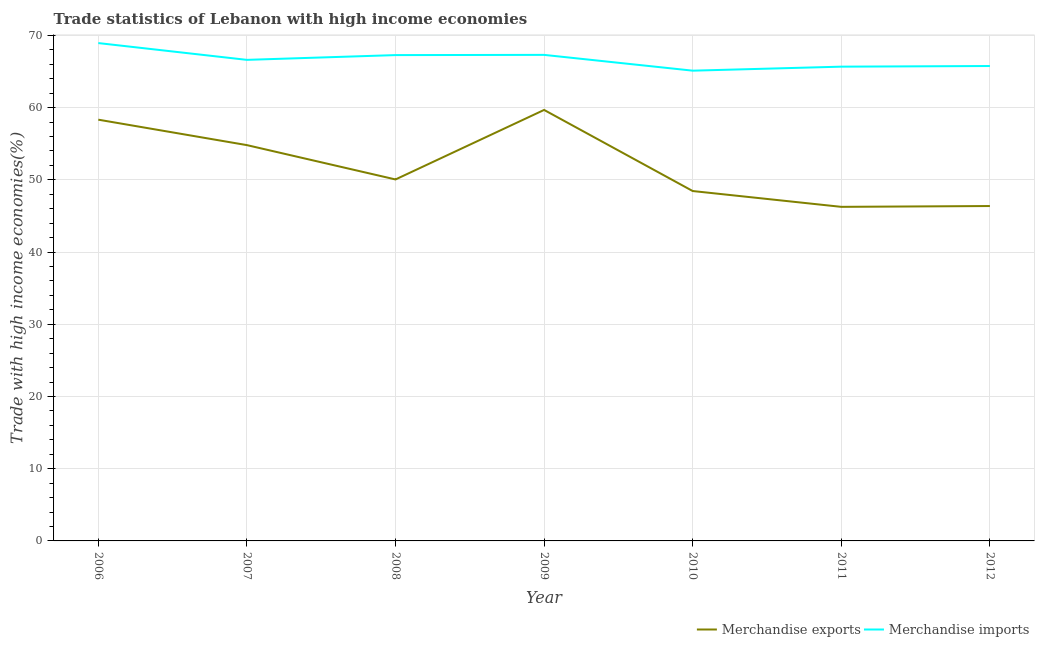How many different coloured lines are there?
Offer a terse response. 2. What is the merchandise exports in 2009?
Your answer should be compact. 59.68. Across all years, what is the maximum merchandise exports?
Your response must be concise. 59.68. Across all years, what is the minimum merchandise exports?
Provide a succinct answer. 46.26. In which year was the merchandise imports minimum?
Make the answer very short. 2010. What is the total merchandise exports in the graph?
Your response must be concise. 363.94. What is the difference between the merchandise exports in 2011 and that in 2012?
Your response must be concise. -0.11. What is the difference between the merchandise exports in 2012 and the merchandise imports in 2008?
Offer a terse response. -20.9. What is the average merchandise exports per year?
Offer a very short reply. 51.99. In the year 2007, what is the difference between the merchandise imports and merchandise exports?
Your answer should be very brief. 11.81. In how many years, is the merchandise imports greater than 12 %?
Keep it short and to the point. 7. What is the ratio of the merchandise exports in 2006 to that in 2012?
Make the answer very short. 1.26. What is the difference between the highest and the second highest merchandise imports?
Offer a very short reply. 1.64. What is the difference between the highest and the lowest merchandise exports?
Give a very brief answer. 13.42. Is the sum of the merchandise exports in 2006 and 2008 greater than the maximum merchandise imports across all years?
Your answer should be very brief. Yes. Is the merchandise exports strictly greater than the merchandise imports over the years?
Provide a short and direct response. No. Is the merchandise exports strictly less than the merchandise imports over the years?
Keep it short and to the point. Yes. How many lines are there?
Offer a terse response. 2. Are the values on the major ticks of Y-axis written in scientific E-notation?
Offer a terse response. No. Does the graph contain any zero values?
Provide a short and direct response. No. Where does the legend appear in the graph?
Your response must be concise. Bottom right. How are the legend labels stacked?
Provide a short and direct response. Horizontal. What is the title of the graph?
Provide a short and direct response. Trade statistics of Lebanon with high income economies. What is the label or title of the X-axis?
Your answer should be very brief. Year. What is the label or title of the Y-axis?
Keep it short and to the point. Trade with high income economies(%). What is the Trade with high income economies(%) in Merchandise exports in 2006?
Offer a very short reply. 58.33. What is the Trade with high income economies(%) of Merchandise imports in 2006?
Your response must be concise. 68.94. What is the Trade with high income economies(%) in Merchandise exports in 2007?
Your answer should be compact. 54.81. What is the Trade with high income economies(%) in Merchandise imports in 2007?
Offer a very short reply. 66.61. What is the Trade with high income economies(%) in Merchandise exports in 2008?
Your answer should be very brief. 50.05. What is the Trade with high income economies(%) of Merchandise imports in 2008?
Give a very brief answer. 67.27. What is the Trade with high income economies(%) of Merchandise exports in 2009?
Make the answer very short. 59.68. What is the Trade with high income economies(%) in Merchandise imports in 2009?
Provide a short and direct response. 67.3. What is the Trade with high income economies(%) in Merchandise exports in 2010?
Provide a succinct answer. 48.45. What is the Trade with high income economies(%) in Merchandise imports in 2010?
Your response must be concise. 65.12. What is the Trade with high income economies(%) of Merchandise exports in 2011?
Give a very brief answer. 46.26. What is the Trade with high income economies(%) of Merchandise imports in 2011?
Offer a very short reply. 65.67. What is the Trade with high income economies(%) of Merchandise exports in 2012?
Offer a terse response. 46.37. What is the Trade with high income economies(%) in Merchandise imports in 2012?
Your response must be concise. 65.76. Across all years, what is the maximum Trade with high income economies(%) in Merchandise exports?
Offer a terse response. 59.68. Across all years, what is the maximum Trade with high income economies(%) in Merchandise imports?
Keep it short and to the point. 68.94. Across all years, what is the minimum Trade with high income economies(%) in Merchandise exports?
Keep it short and to the point. 46.26. Across all years, what is the minimum Trade with high income economies(%) in Merchandise imports?
Your answer should be very brief. 65.12. What is the total Trade with high income economies(%) of Merchandise exports in the graph?
Offer a very short reply. 363.94. What is the total Trade with high income economies(%) in Merchandise imports in the graph?
Your response must be concise. 466.66. What is the difference between the Trade with high income economies(%) of Merchandise exports in 2006 and that in 2007?
Offer a very short reply. 3.52. What is the difference between the Trade with high income economies(%) in Merchandise imports in 2006 and that in 2007?
Offer a very short reply. 2.33. What is the difference between the Trade with high income economies(%) of Merchandise exports in 2006 and that in 2008?
Make the answer very short. 8.28. What is the difference between the Trade with high income economies(%) in Merchandise imports in 2006 and that in 2008?
Offer a very short reply. 1.66. What is the difference between the Trade with high income economies(%) of Merchandise exports in 2006 and that in 2009?
Your answer should be compact. -1.35. What is the difference between the Trade with high income economies(%) in Merchandise imports in 2006 and that in 2009?
Your answer should be compact. 1.64. What is the difference between the Trade with high income economies(%) in Merchandise exports in 2006 and that in 2010?
Offer a terse response. 9.88. What is the difference between the Trade with high income economies(%) of Merchandise imports in 2006 and that in 2010?
Keep it short and to the point. 3.82. What is the difference between the Trade with high income economies(%) of Merchandise exports in 2006 and that in 2011?
Your answer should be compact. 12.07. What is the difference between the Trade with high income economies(%) of Merchandise imports in 2006 and that in 2011?
Your answer should be compact. 3.27. What is the difference between the Trade with high income economies(%) in Merchandise exports in 2006 and that in 2012?
Keep it short and to the point. 11.96. What is the difference between the Trade with high income economies(%) of Merchandise imports in 2006 and that in 2012?
Ensure brevity in your answer.  3.18. What is the difference between the Trade with high income economies(%) of Merchandise exports in 2007 and that in 2008?
Your answer should be very brief. 4.75. What is the difference between the Trade with high income economies(%) of Merchandise imports in 2007 and that in 2008?
Your answer should be compact. -0.66. What is the difference between the Trade with high income economies(%) of Merchandise exports in 2007 and that in 2009?
Give a very brief answer. -4.87. What is the difference between the Trade with high income economies(%) of Merchandise imports in 2007 and that in 2009?
Offer a terse response. -0.69. What is the difference between the Trade with high income economies(%) in Merchandise exports in 2007 and that in 2010?
Provide a short and direct response. 6.36. What is the difference between the Trade with high income economies(%) in Merchandise imports in 2007 and that in 2010?
Provide a succinct answer. 1.5. What is the difference between the Trade with high income economies(%) of Merchandise exports in 2007 and that in 2011?
Keep it short and to the point. 8.55. What is the difference between the Trade with high income economies(%) of Merchandise imports in 2007 and that in 2011?
Make the answer very short. 0.94. What is the difference between the Trade with high income economies(%) of Merchandise exports in 2007 and that in 2012?
Offer a terse response. 8.44. What is the difference between the Trade with high income economies(%) of Merchandise imports in 2007 and that in 2012?
Provide a succinct answer. 0.85. What is the difference between the Trade with high income economies(%) in Merchandise exports in 2008 and that in 2009?
Give a very brief answer. -9.63. What is the difference between the Trade with high income economies(%) in Merchandise imports in 2008 and that in 2009?
Your response must be concise. -0.03. What is the difference between the Trade with high income economies(%) of Merchandise exports in 2008 and that in 2010?
Offer a terse response. 1.6. What is the difference between the Trade with high income economies(%) in Merchandise imports in 2008 and that in 2010?
Make the answer very short. 2.16. What is the difference between the Trade with high income economies(%) in Merchandise exports in 2008 and that in 2011?
Offer a very short reply. 3.79. What is the difference between the Trade with high income economies(%) in Merchandise imports in 2008 and that in 2011?
Provide a succinct answer. 1.6. What is the difference between the Trade with high income economies(%) of Merchandise exports in 2008 and that in 2012?
Provide a short and direct response. 3.68. What is the difference between the Trade with high income economies(%) in Merchandise imports in 2008 and that in 2012?
Provide a succinct answer. 1.51. What is the difference between the Trade with high income economies(%) in Merchandise exports in 2009 and that in 2010?
Make the answer very short. 11.23. What is the difference between the Trade with high income economies(%) in Merchandise imports in 2009 and that in 2010?
Provide a succinct answer. 2.19. What is the difference between the Trade with high income economies(%) in Merchandise exports in 2009 and that in 2011?
Your answer should be compact. 13.42. What is the difference between the Trade with high income economies(%) of Merchandise imports in 2009 and that in 2011?
Make the answer very short. 1.63. What is the difference between the Trade with high income economies(%) in Merchandise exports in 2009 and that in 2012?
Provide a short and direct response. 13.31. What is the difference between the Trade with high income economies(%) in Merchandise imports in 2009 and that in 2012?
Give a very brief answer. 1.54. What is the difference between the Trade with high income economies(%) of Merchandise exports in 2010 and that in 2011?
Give a very brief answer. 2.19. What is the difference between the Trade with high income economies(%) of Merchandise imports in 2010 and that in 2011?
Make the answer very short. -0.56. What is the difference between the Trade with high income economies(%) of Merchandise exports in 2010 and that in 2012?
Give a very brief answer. 2.08. What is the difference between the Trade with high income economies(%) in Merchandise imports in 2010 and that in 2012?
Offer a very short reply. -0.64. What is the difference between the Trade with high income economies(%) of Merchandise exports in 2011 and that in 2012?
Ensure brevity in your answer.  -0.11. What is the difference between the Trade with high income economies(%) in Merchandise imports in 2011 and that in 2012?
Ensure brevity in your answer.  -0.09. What is the difference between the Trade with high income economies(%) in Merchandise exports in 2006 and the Trade with high income economies(%) in Merchandise imports in 2007?
Offer a very short reply. -8.28. What is the difference between the Trade with high income economies(%) of Merchandise exports in 2006 and the Trade with high income economies(%) of Merchandise imports in 2008?
Your answer should be very brief. -8.94. What is the difference between the Trade with high income economies(%) in Merchandise exports in 2006 and the Trade with high income economies(%) in Merchandise imports in 2009?
Make the answer very short. -8.97. What is the difference between the Trade with high income economies(%) in Merchandise exports in 2006 and the Trade with high income economies(%) in Merchandise imports in 2010?
Offer a very short reply. -6.79. What is the difference between the Trade with high income economies(%) in Merchandise exports in 2006 and the Trade with high income economies(%) in Merchandise imports in 2011?
Make the answer very short. -7.34. What is the difference between the Trade with high income economies(%) in Merchandise exports in 2006 and the Trade with high income economies(%) in Merchandise imports in 2012?
Offer a terse response. -7.43. What is the difference between the Trade with high income economies(%) in Merchandise exports in 2007 and the Trade with high income economies(%) in Merchandise imports in 2008?
Your answer should be compact. -12.47. What is the difference between the Trade with high income economies(%) in Merchandise exports in 2007 and the Trade with high income economies(%) in Merchandise imports in 2009?
Make the answer very short. -12.49. What is the difference between the Trade with high income economies(%) in Merchandise exports in 2007 and the Trade with high income economies(%) in Merchandise imports in 2010?
Offer a very short reply. -10.31. What is the difference between the Trade with high income economies(%) of Merchandise exports in 2007 and the Trade with high income economies(%) of Merchandise imports in 2011?
Make the answer very short. -10.86. What is the difference between the Trade with high income economies(%) of Merchandise exports in 2007 and the Trade with high income economies(%) of Merchandise imports in 2012?
Make the answer very short. -10.95. What is the difference between the Trade with high income economies(%) in Merchandise exports in 2008 and the Trade with high income economies(%) in Merchandise imports in 2009?
Your response must be concise. -17.25. What is the difference between the Trade with high income economies(%) in Merchandise exports in 2008 and the Trade with high income economies(%) in Merchandise imports in 2010?
Ensure brevity in your answer.  -15.06. What is the difference between the Trade with high income economies(%) of Merchandise exports in 2008 and the Trade with high income economies(%) of Merchandise imports in 2011?
Give a very brief answer. -15.62. What is the difference between the Trade with high income economies(%) of Merchandise exports in 2008 and the Trade with high income economies(%) of Merchandise imports in 2012?
Your answer should be compact. -15.71. What is the difference between the Trade with high income economies(%) of Merchandise exports in 2009 and the Trade with high income economies(%) of Merchandise imports in 2010?
Provide a succinct answer. -5.44. What is the difference between the Trade with high income economies(%) of Merchandise exports in 2009 and the Trade with high income economies(%) of Merchandise imports in 2011?
Make the answer very short. -5.99. What is the difference between the Trade with high income economies(%) in Merchandise exports in 2009 and the Trade with high income economies(%) in Merchandise imports in 2012?
Keep it short and to the point. -6.08. What is the difference between the Trade with high income economies(%) of Merchandise exports in 2010 and the Trade with high income economies(%) of Merchandise imports in 2011?
Your response must be concise. -17.22. What is the difference between the Trade with high income economies(%) of Merchandise exports in 2010 and the Trade with high income economies(%) of Merchandise imports in 2012?
Your response must be concise. -17.31. What is the difference between the Trade with high income economies(%) of Merchandise exports in 2011 and the Trade with high income economies(%) of Merchandise imports in 2012?
Your answer should be very brief. -19.5. What is the average Trade with high income economies(%) in Merchandise exports per year?
Your response must be concise. 51.99. What is the average Trade with high income economies(%) of Merchandise imports per year?
Give a very brief answer. 66.67. In the year 2006, what is the difference between the Trade with high income economies(%) in Merchandise exports and Trade with high income economies(%) in Merchandise imports?
Provide a short and direct response. -10.61. In the year 2007, what is the difference between the Trade with high income economies(%) in Merchandise exports and Trade with high income economies(%) in Merchandise imports?
Keep it short and to the point. -11.81. In the year 2008, what is the difference between the Trade with high income economies(%) in Merchandise exports and Trade with high income economies(%) in Merchandise imports?
Your answer should be compact. -17.22. In the year 2009, what is the difference between the Trade with high income economies(%) of Merchandise exports and Trade with high income economies(%) of Merchandise imports?
Provide a short and direct response. -7.62. In the year 2010, what is the difference between the Trade with high income economies(%) in Merchandise exports and Trade with high income economies(%) in Merchandise imports?
Your answer should be very brief. -16.67. In the year 2011, what is the difference between the Trade with high income economies(%) in Merchandise exports and Trade with high income economies(%) in Merchandise imports?
Your response must be concise. -19.41. In the year 2012, what is the difference between the Trade with high income economies(%) of Merchandise exports and Trade with high income economies(%) of Merchandise imports?
Your answer should be compact. -19.39. What is the ratio of the Trade with high income economies(%) in Merchandise exports in 2006 to that in 2007?
Offer a terse response. 1.06. What is the ratio of the Trade with high income economies(%) in Merchandise imports in 2006 to that in 2007?
Make the answer very short. 1.03. What is the ratio of the Trade with high income economies(%) of Merchandise exports in 2006 to that in 2008?
Provide a short and direct response. 1.17. What is the ratio of the Trade with high income economies(%) of Merchandise imports in 2006 to that in 2008?
Your answer should be compact. 1.02. What is the ratio of the Trade with high income economies(%) of Merchandise exports in 2006 to that in 2009?
Offer a terse response. 0.98. What is the ratio of the Trade with high income economies(%) of Merchandise imports in 2006 to that in 2009?
Your response must be concise. 1.02. What is the ratio of the Trade with high income economies(%) in Merchandise exports in 2006 to that in 2010?
Keep it short and to the point. 1.2. What is the ratio of the Trade with high income economies(%) in Merchandise imports in 2006 to that in 2010?
Your response must be concise. 1.06. What is the ratio of the Trade with high income economies(%) of Merchandise exports in 2006 to that in 2011?
Offer a very short reply. 1.26. What is the ratio of the Trade with high income economies(%) in Merchandise imports in 2006 to that in 2011?
Ensure brevity in your answer.  1.05. What is the ratio of the Trade with high income economies(%) in Merchandise exports in 2006 to that in 2012?
Your answer should be very brief. 1.26. What is the ratio of the Trade with high income economies(%) in Merchandise imports in 2006 to that in 2012?
Offer a terse response. 1.05. What is the ratio of the Trade with high income economies(%) of Merchandise exports in 2007 to that in 2008?
Your answer should be compact. 1.09. What is the ratio of the Trade with high income economies(%) of Merchandise imports in 2007 to that in 2008?
Make the answer very short. 0.99. What is the ratio of the Trade with high income economies(%) of Merchandise exports in 2007 to that in 2009?
Provide a succinct answer. 0.92. What is the ratio of the Trade with high income economies(%) in Merchandise exports in 2007 to that in 2010?
Offer a very short reply. 1.13. What is the ratio of the Trade with high income economies(%) of Merchandise imports in 2007 to that in 2010?
Provide a succinct answer. 1.02. What is the ratio of the Trade with high income economies(%) of Merchandise exports in 2007 to that in 2011?
Your response must be concise. 1.18. What is the ratio of the Trade with high income economies(%) in Merchandise imports in 2007 to that in 2011?
Your answer should be compact. 1.01. What is the ratio of the Trade with high income economies(%) in Merchandise exports in 2007 to that in 2012?
Your answer should be very brief. 1.18. What is the ratio of the Trade with high income economies(%) of Merchandise imports in 2007 to that in 2012?
Keep it short and to the point. 1.01. What is the ratio of the Trade with high income economies(%) in Merchandise exports in 2008 to that in 2009?
Your answer should be very brief. 0.84. What is the ratio of the Trade with high income economies(%) in Merchandise exports in 2008 to that in 2010?
Give a very brief answer. 1.03. What is the ratio of the Trade with high income economies(%) in Merchandise imports in 2008 to that in 2010?
Give a very brief answer. 1.03. What is the ratio of the Trade with high income economies(%) of Merchandise exports in 2008 to that in 2011?
Your response must be concise. 1.08. What is the ratio of the Trade with high income economies(%) in Merchandise imports in 2008 to that in 2011?
Keep it short and to the point. 1.02. What is the ratio of the Trade with high income economies(%) of Merchandise exports in 2008 to that in 2012?
Make the answer very short. 1.08. What is the ratio of the Trade with high income economies(%) of Merchandise imports in 2008 to that in 2012?
Your answer should be very brief. 1.02. What is the ratio of the Trade with high income economies(%) in Merchandise exports in 2009 to that in 2010?
Your response must be concise. 1.23. What is the ratio of the Trade with high income economies(%) in Merchandise imports in 2009 to that in 2010?
Offer a terse response. 1.03. What is the ratio of the Trade with high income economies(%) in Merchandise exports in 2009 to that in 2011?
Offer a terse response. 1.29. What is the ratio of the Trade with high income economies(%) in Merchandise imports in 2009 to that in 2011?
Offer a very short reply. 1.02. What is the ratio of the Trade with high income economies(%) in Merchandise exports in 2009 to that in 2012?
Give a very brief answer. 1.29. What is the ratio of the Trade with high income economies(%) in Merchandise imports in 2009 to that in 2012?
Make the answer very short. 1.02. What is the ratio of the Trade with high income economies(%) of Merchandise exports in 2010 to that in 2011?
Give a very brief answer. 1.05. What is the ratio of the Trade with high income economies(%) in Merchandise imports in 2010 to that in 2011?
Provide a short and direct response. 0.99. What is the ratio of the Trade with high income economies(%) in Merchandise exports in 2010 to that in 2012?
Give a very brief answer. 1.04. What is the ratio of the Trade with high income economies(%) in Merchandise imports in 2010 to that in 2012?
Ensure brevity in your answer.  0.99. What is the ratio of the Trade with high income economies(%) in Merchandise exports in 2011 to that in 2012?
Make the answer very short. 1. What is the ratio of the Trade with high income economies(%) of Merchandise imports in 2011 to that in 2012?
Give a very brief answer. 1. What is the difference between the highest and the second highest Trade with high income economies(%) in Merchandise exports?
Offer a very short reply. 1.35. What is the difference between the highest and the second highest Trade with high income economies(%) of Merchandise imports?
Your answer should be very brief. 1.64. What is the difference between the highest and the lowest Trade with high income economies(%) of Merchandise exports?
Keep it short and to the point. 13.42. What is the difference between the highest and the lowest Trade with high income economies(%) of Merchandise imports?
Provide a succinct answer. 3.82. 